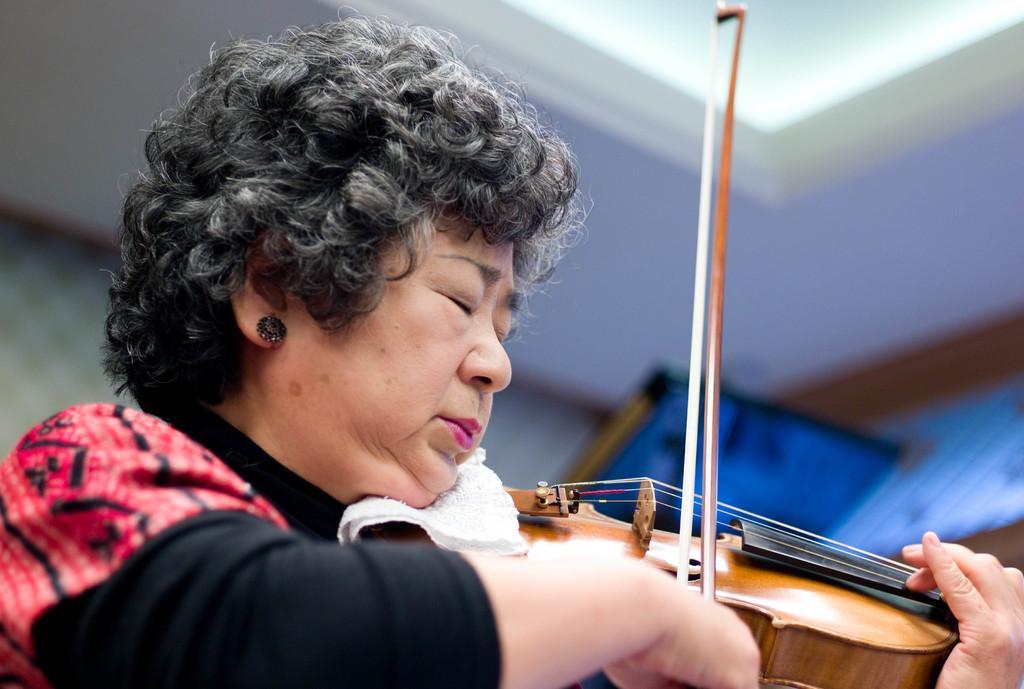Describe this image in one or two sentences. The woman is closing her eyes and playing violin. 